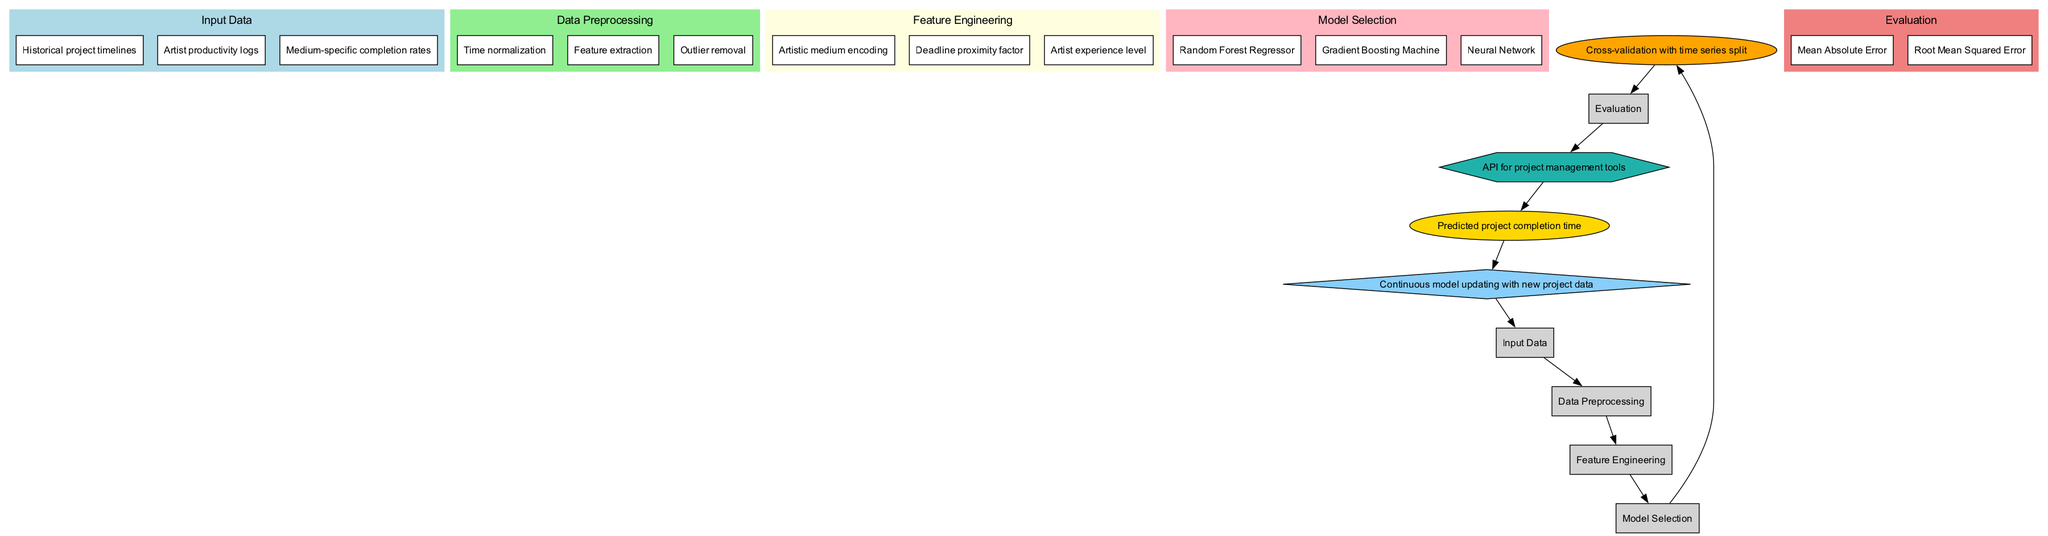What are the input data points in the diagram? The diagram lists three input data points: Historical project timelines, Artist productivity logs, and Medium-specific completion rates. These are clearly indicated in the "Input Data" section.
Answer: Historical project timelines, Artist productivity logs, Medium-specific completion rates What is the first stage in the pipeline? The first stage in the pipeline is "Input Data," which leads to the next step of "Data Preprocessing." This is represented by the directional arrow from the "Input Data" node to the "Data Preprocessing" node.
Answer: Input Data How many models are selected for the prediction? There are three models selected for the prediction, which include Random Forest Regressor, Gradient Boosting Machine, and Neural Network. These are listed under the "Model Selection" section of the diagram.
Answer: 3 What is the evaluation metric mentioned in the diagram? The evaluation metrics mentioned are Mean Absolute Error and Root Mean Squared Error, which are located in the "Evaluation" section. Both metrics are aimed at assessing the performance of the models.
Answer: Mean Absolute Error, Root Mean Squared Error What follows the training phase in the pipeline? After the training phase, the next step in the pipeline is "Evaluation." This is shown by the arrow connecting the "Training" node to the "Evaluation" node, indicating the flow of information.
Answer: Evaluation What is the shape of the Deployment node? The shape of the Deployment node is a hexagon, which is a distinctive feature that differentiates it from other stages in the pipeline, such as rectangles and ellipses used for other nodes.
Answer: Hexagon How does the feedback loop integrate with the pipeline? The feedback loop is connected back to the input data, indicating that it's used for continuous model updating with new project data. This is shown by the arrow from the "Feedback Loop" node back to the "Input Data" node.
Answer: Continuous model updating What type of regression approaches are represented in the model selection? The model selection includes Random Forest Regressor, Gradient Boosting Machine, and Neural Network, all of which are regression approaches suited for predicting continuous outcomes like project completion times.
Answer: Regression approaches What kind of API is mentioned for deployment? The API mentioned for deployment is designed for project management tools, indicating its practical application within the industry to aid in project completion predictions.
Answer: API for project management tools 